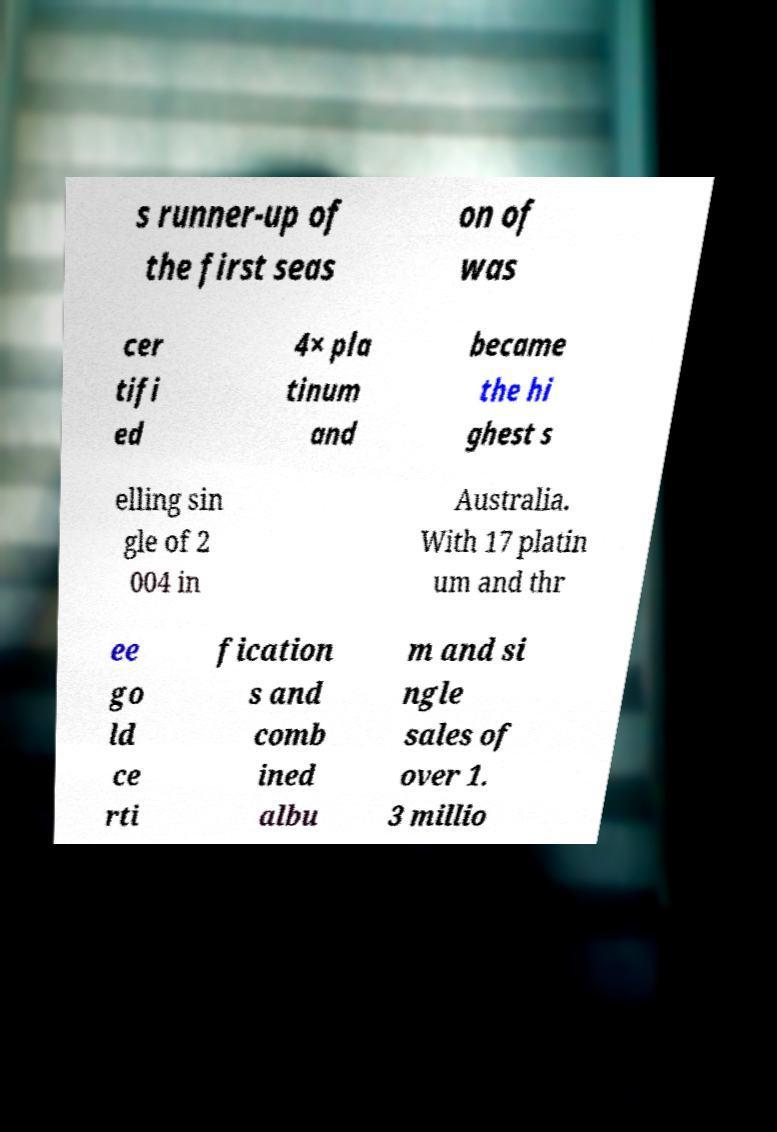Please read and relay the text visible in this image. What does it say? s runner-up of the first seas on of was cer tifi ed 4× pla tinum and became the hi ghest s elling sin gle of 2 004 in Australia. With 17 platin um and thr ee go ld ce rti fication s and comb ined albu m and si ngle sales of over 1. 3 millio 